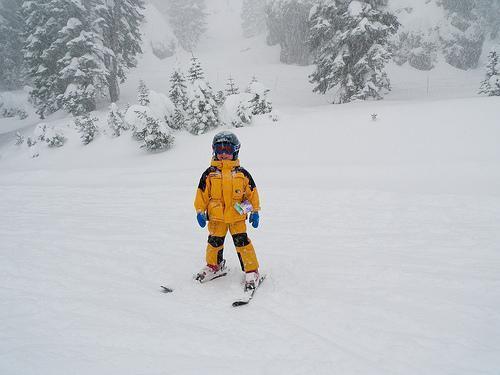How many people in the picture?
Give a very brief answer. 1. 